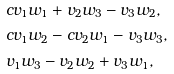Convert formula to latex. <formula><loc_0><loc_0><loc_500><loc_500>& c v _ { 1 } w _ { 1 } + v _ { 2 } w _ { 3 } - v _ { 3 } w _ { 2 } , \\ & c v _ { 1 } w _ { 2 } - c v _ { 2 } w _ { 1 } - v _ { 3 } w _ { 3 } , \\ & v _ { 1 } w _ { 3 } - v _ { 2 } w _ { 2 } + v _ { 3 } w _ { 1 } ,</formula> 